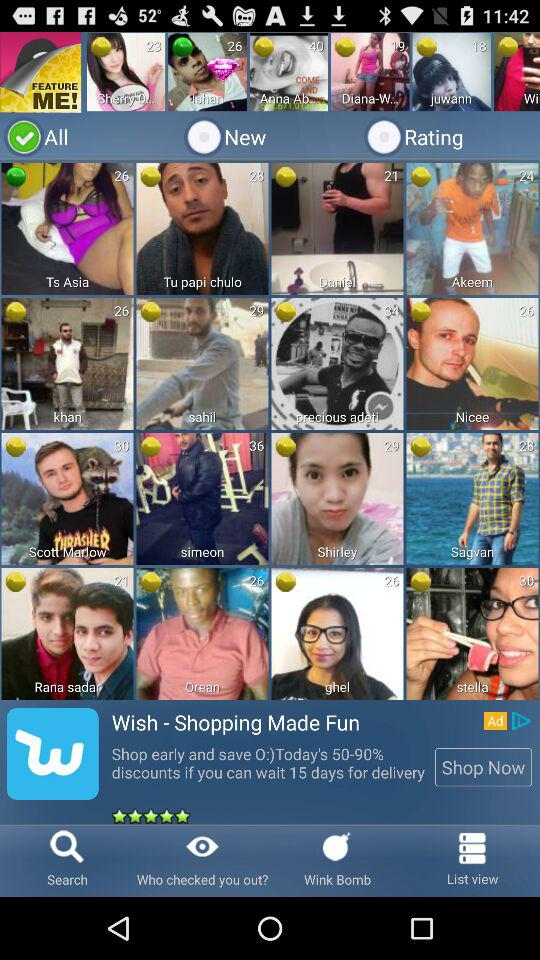Which option is selected? The selected option is "All". 